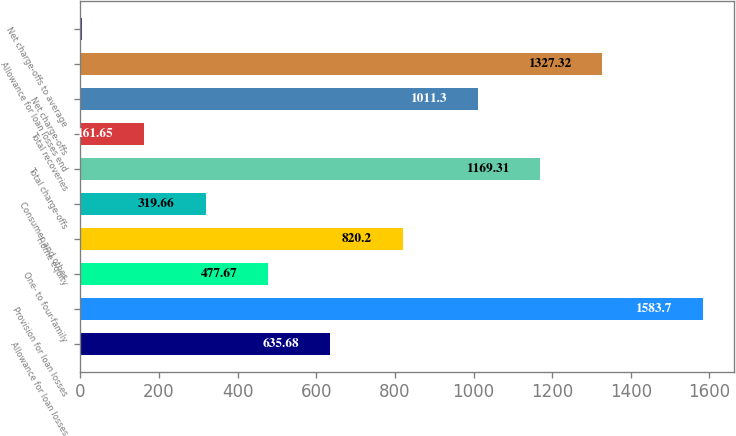Convert chart. <chart><loc_0><loc_0><loc_500><loc_500><bar_chart><fcel>Allowance for loan losses<fcel>Provision for loan losses<fcel>One- to four-family<fcel>Home equity<fcel>Consumer and other<fcel>Total charge-offs<fcel>Total recoveries<fcel>Net charge-offs<fcel>Allowance for loan losses end<fcel>Net charge-offs to average<nl><fcel>635.68<fcel>1583.7<fcel>477.67<fcel>820.2<fcel>319.66<fcel>1169.31<fcel>161.65<fcel>1011.3<fcel>1327.32<fcel>3.64<nl></chart> 